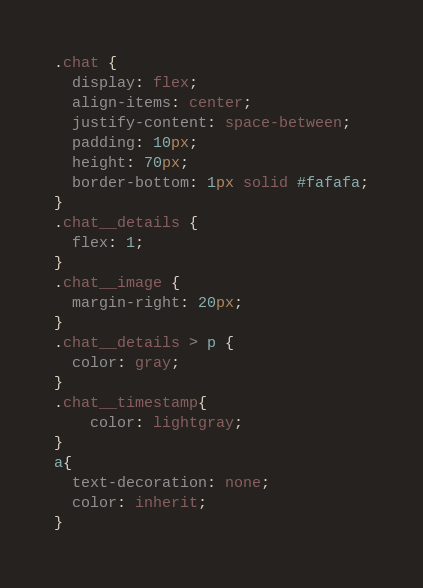<code> <loc_0><loc_0><loc_500><loc_500><_CSS_>.chat {
  display: flex;
  align-items: center;
  justify-content: space-between;
  padding: 10px;
  height: 70px;
  border-bottom: 1px solid #fafafa;
}
.chat__details {
  flex: 1;
}
.chat__image {
  margin-right: 20px;
}
.chat__details > p {
  color: gray;
}
.chat__timestamp{
    color: lightgray;
}
a{
  text-decoration: none;
  color: inherit;
}</code> 